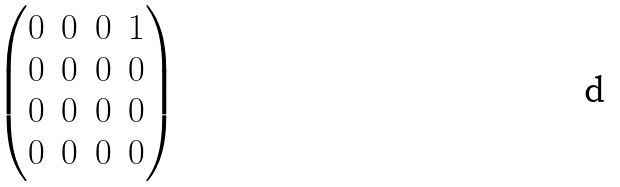Convert formula to latex. <formula><loc_0><loc_0><loc_500><loc_500>\begin{pmatrix} 0 & 0 & 0 & 1 \\ 0 & 0 & 0 & 0 \\ 0 & 0 & 0 & 0 \\ 0 & 0 & 0 & 0 \\ \end{pmatrix}</formula> 